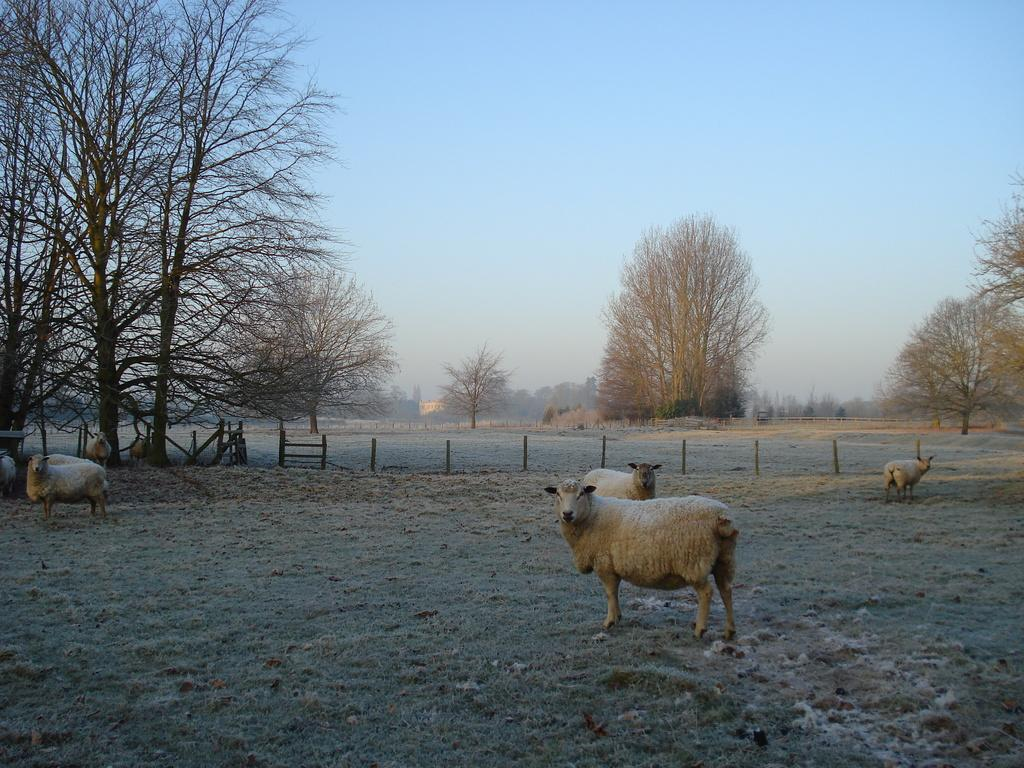What is visible in the background of the image? The sky is visible in the image. What type of vegetation can be seen in the image? There are trees in the image. What type of barrier is present in the image? There is a wooden fence in the image. What type of animals can be seen in the image? There is a flock standing on the ground in the image. What type of prose is being recited by the animals in the image? There is no indication in the image that the animals are reciting any prose. How many rings are visible on the wooden fence in the image? There are no rings visible on the wooden fence in the image. 